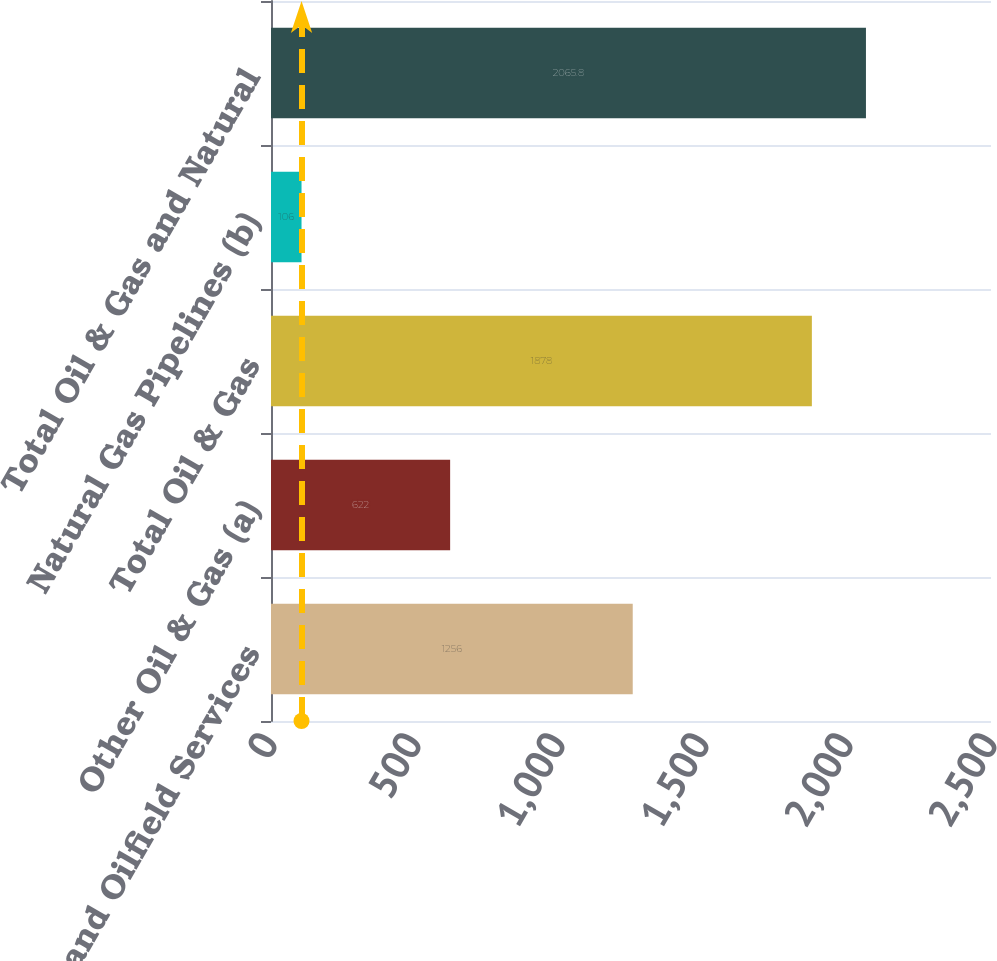Convert chart. <chart><loc_0><loc_0><loc_500><loc_500><bar_chart><fcel>E&P and Oilfield Services<fcel>Other Oil & Gas (a)<fcel>Total Oil & Gas<fcel>Natural Gas Pipelines (b)<fcel>Total Oil & Gas and Natural<nl><fcel>1256<fcel>622<fcel>1878<fcel>106<fcel>2065.8<nl></chart> 